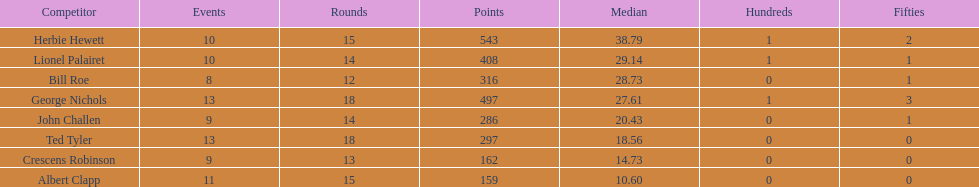How many more runs does john have than albert? 127. 